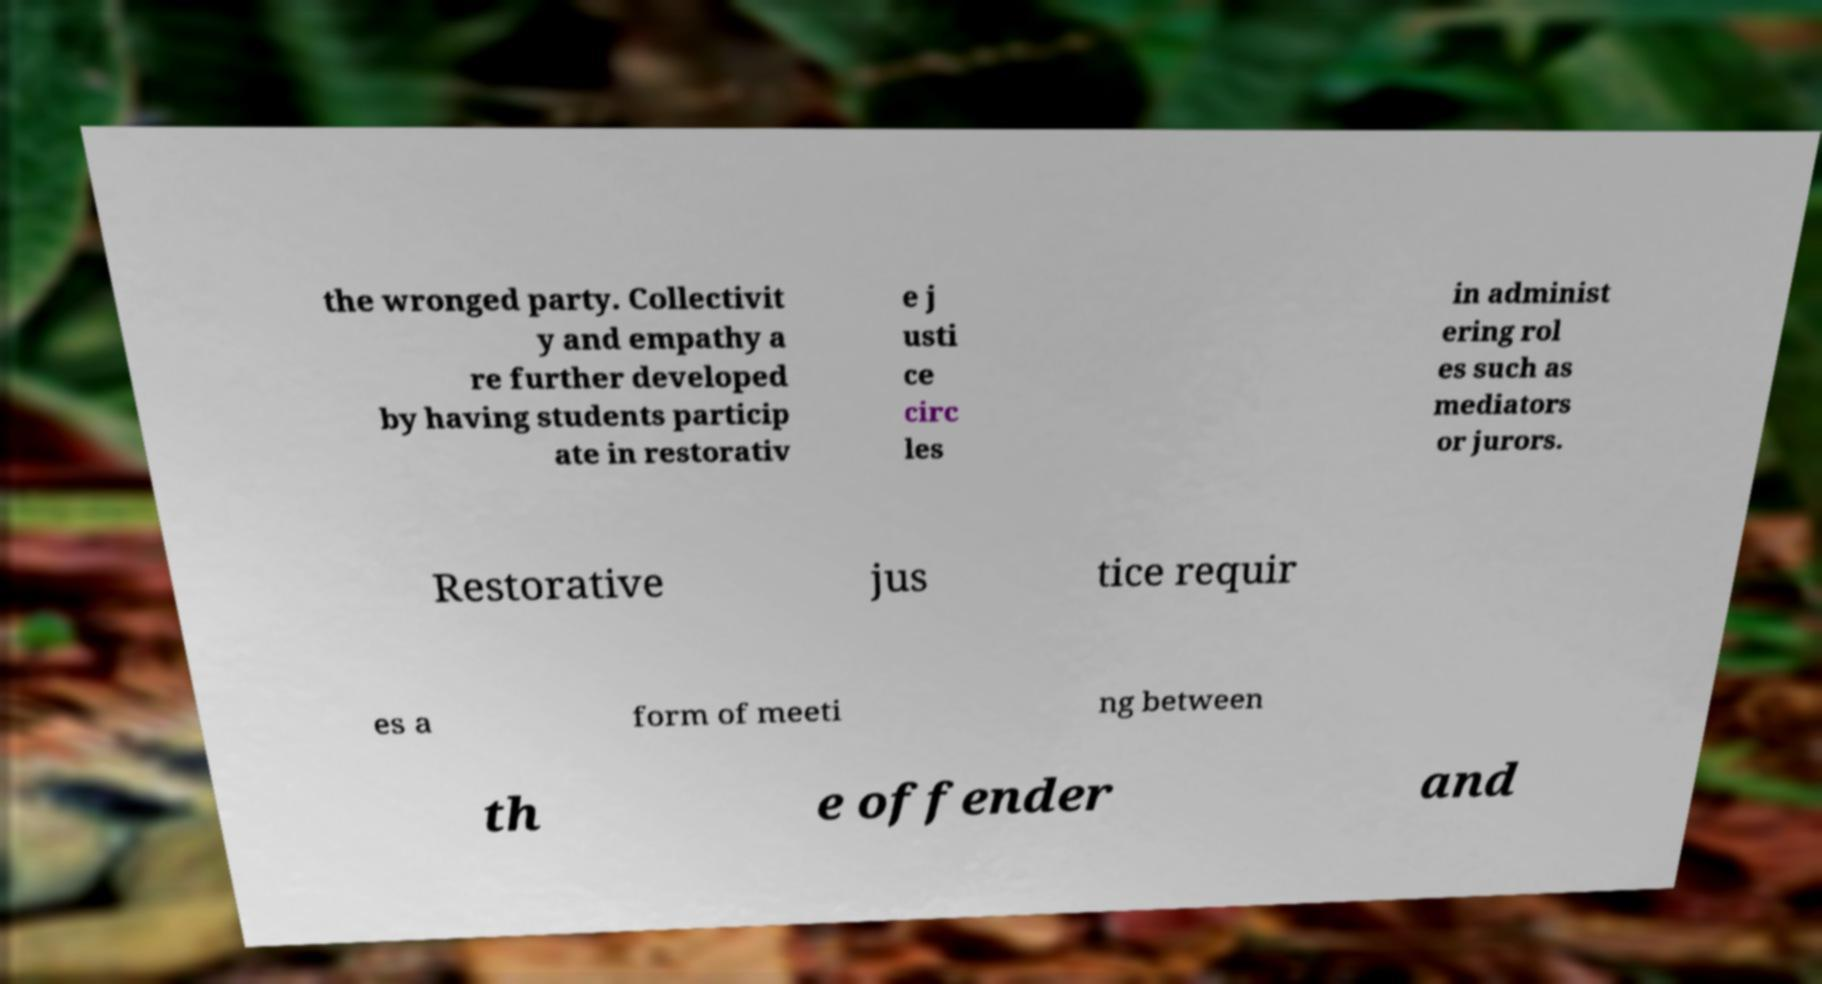Could you assist in decoding the text presented in this image and type it out clearly? the wronged party. Collectivit y and empathy a re further developed by having students particip ate in restorativ e j usti ce circ les in administ ering rol es such as mediators or jurors. Restorative jus tice requir es a form of meeti ng between th e offender and 